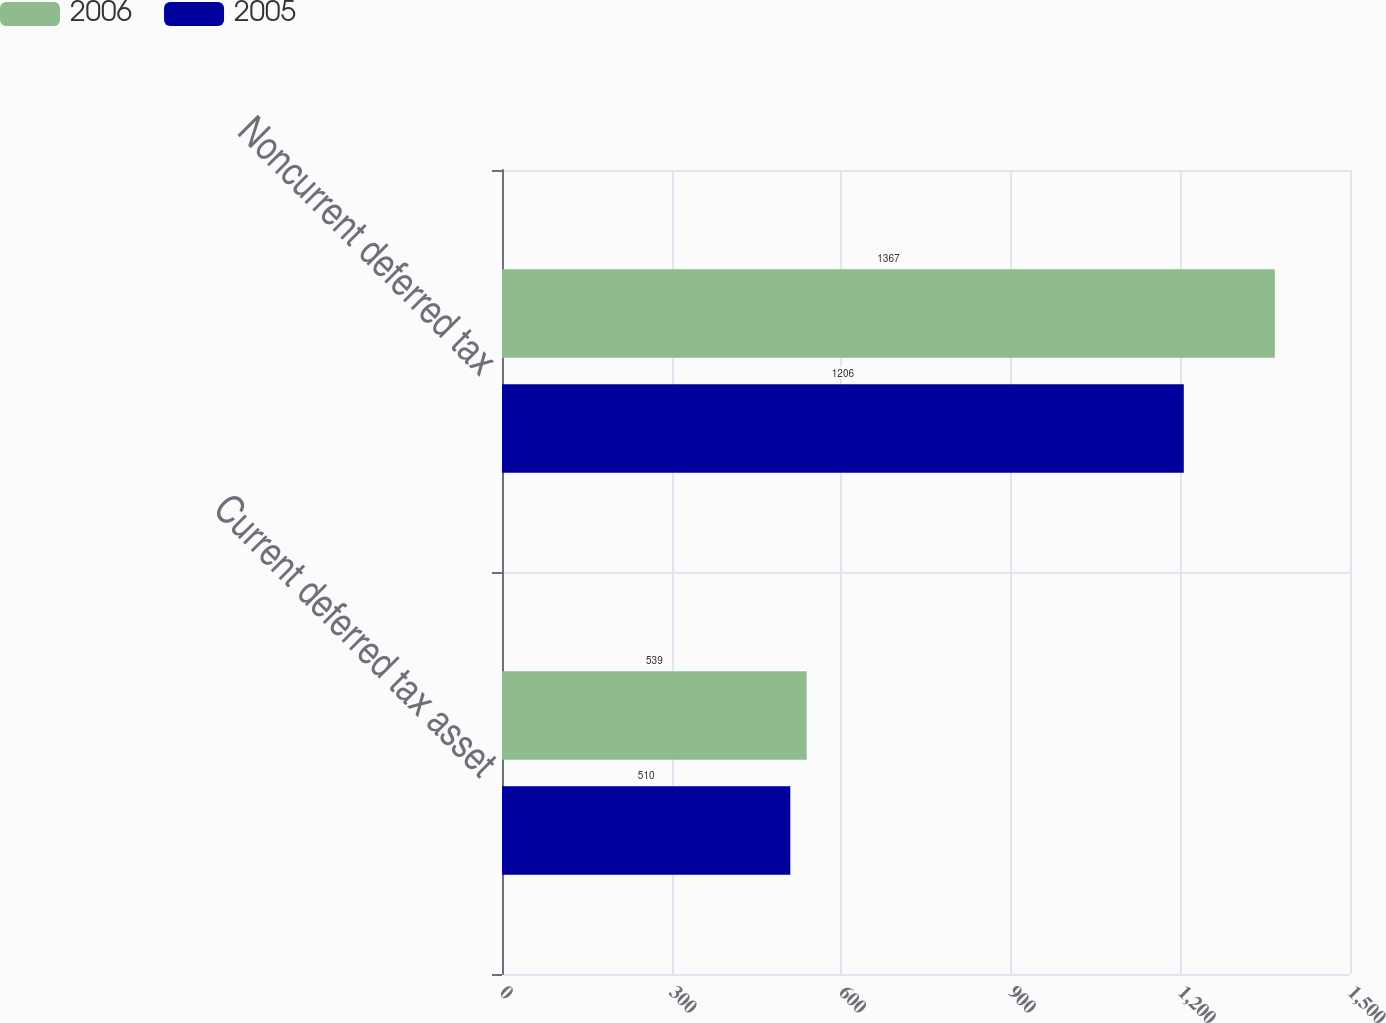Convert chart. <chart><loc_0><loc_0><loc_500><loc_500><stacked_bar_chart><ecel><fcel>Current deferred tax asset<fcel>Noncurrent deferred tax<nl><fcel>2006<fcel>539<fcel>1367<nl><fcel>2005<fcel>510<fcel>1206<nl></chart> 